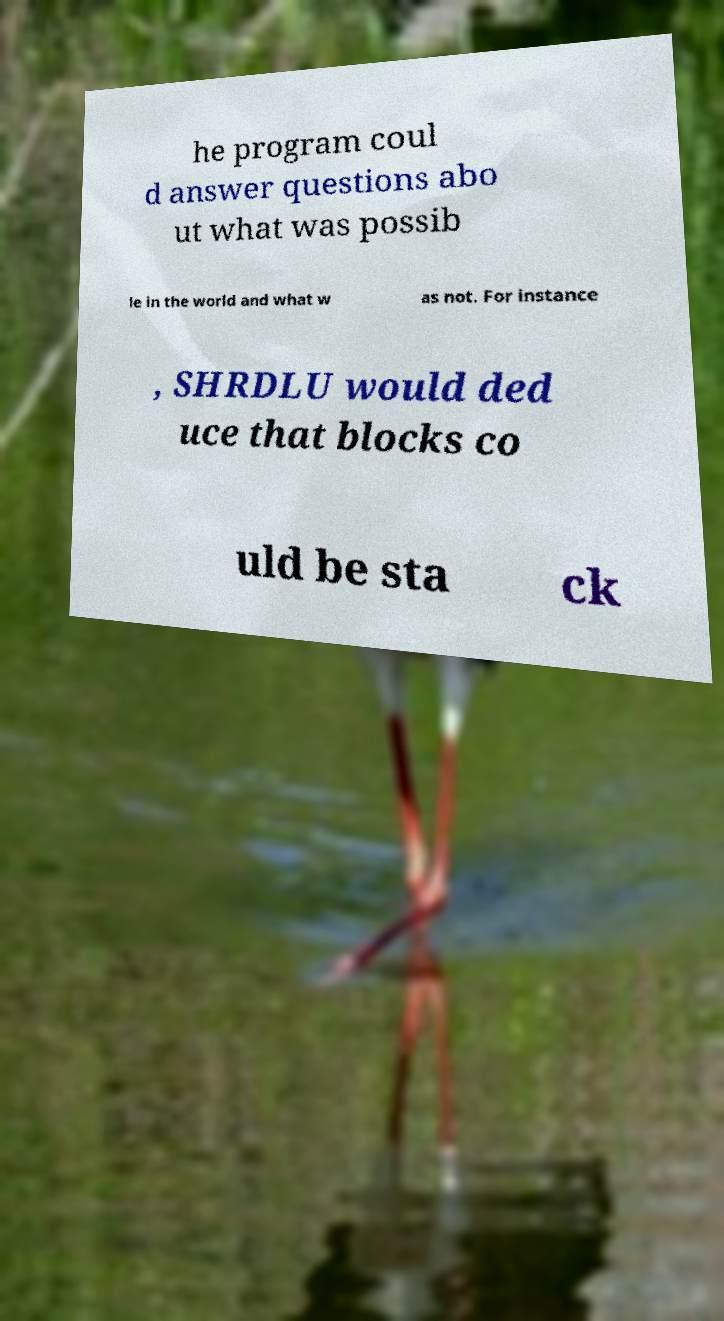Could you assist in decoding the text presented in this image and type it out clearly? he program coul d answer questions abo ut what was possib le in the world and what w as not. For instance , SHRDLU would ded uce that blocks co uld be sta ck 